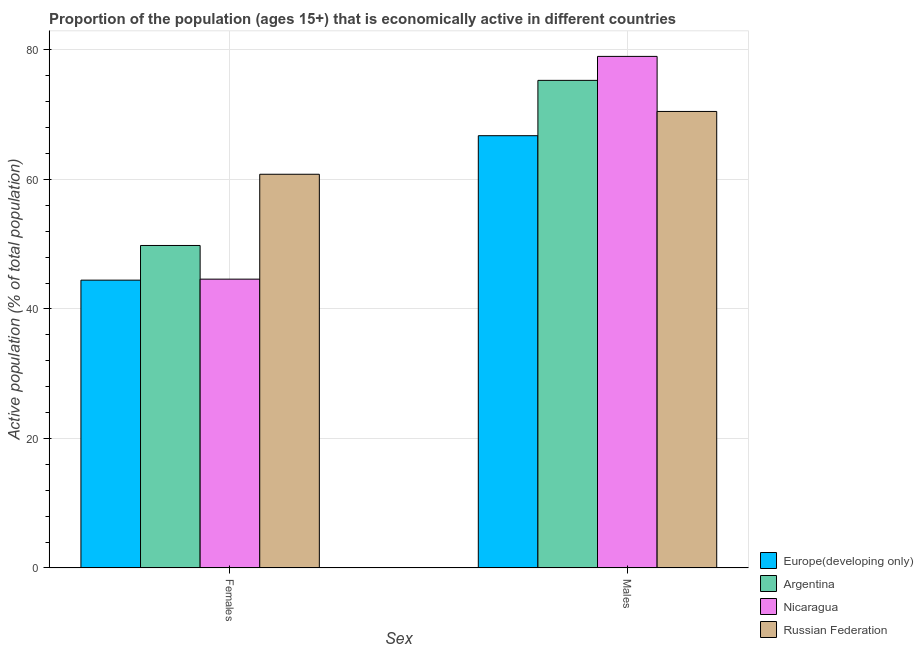How many different coloured bars are there?
Ensure brevity in your answer.  4. Are the number of bars per tick equal to the number of legend labels?
Offer a very short reply. Yes. Are the number of bars on each tick of the X-axis equal?
Your answer should be very brief. Yes. How many bars are there on the 2nd tick from the left?
Your answer should be compact. 4. What is the label of the 1st group of bars from the left?
Offer a very short reply. Females. What is the percentage of economically active female population in Argentina?
Keep it short and to the point. 49.8. Across all countries, what is the maximum percentage of economically active male population?
Offer a very short reply. 79. Across all countries, what is the minimum percentage of economically active female population?
Your answer should be very brief. 44.45. In which country was the percentage of economically active male population maximum?
Provide a succinct answer. Nicaragua. In which country was the percentage of economically active male population minimum?
Make the answer very short. Europe(developing only). What is the total percentage of economically active female population in the graph?
Offer a very short reply. 199.65. What is the difference between the percentage of economically active female population in Russian Federation and that in Nicaragua?
Provide a succinct answer. 16.2. What is the difference between the percentage of economically active male population in Russian Federation and the percentage of economically active female population in Nicaragua?
Provide a succinct answer. 25.9. What is the average percentage of economically active male population per country?
Provide a succinct answer. 72.89. What is the difference between the percentage of economically active female population and percentage of economically active male population in Russian Federation?
Your answer should be very brief. -9.7. What is the ratio of the percentage of economically active male population in Europe(developing only) to that in Nicaragua?
Provide a short and direct response. 0.84. Is the percentage of economically active female population in Nicaragua less than that in Europe(developing only)?
Your answer should be compact. No. What does the 1st bar from the left in Males represents?
Ensure brevity in your answer.  Europe(developing only). What does the 2nd bar from the right in Males represents?
Your answer should be compact. Nicaragua. How many bars are there?
Make the answer very short. 8. How many countries are there in the graph?
Provide a succinct answer. 4. What is the difference between two consecutive major ticks on the Y-axis?
Make the answer very short. 20. Are the values on the major ticks of Y-axis written in scientific E-notation?
Make the answer very short. No. Does the graph contain any zero values?
Ensure brevity in your answer.  No. Does the graph contain grids?
Your response must be concise. Yes. Where does the legend appear in the graph?
Ensure brevity in your answer.  Bottom right. What is the title of the graph?
Make the answer very short. Proportion of the population (ages 15+) that is economically active in different countries. What is the label or title of the X-axis?
Give a very brief answer. Sex. What is the label or title of the Y-axis?
Make the answer very short. Active population (% of total population). What is the Active population (% of total population) in Europe(developing only) in Females?
Make the answer very short. 44.45. What is the Active population (% of total population) of Argentina in Females?
Ensure brevity in your answer.  49.8. What is the Active population (% of total population) of Nicaragua in Females?
Keep it short and to the point. 44.6. What is the Active population (% of total population) of Russian Federation in Females?
Your answer should be compact. 60.8. What is the Active population (% of total population) of Europe(developing only) in Males?
Give a very brief answer. 66.75. What is the Active population (% of total population) in Argentina in Males?
Provide a short and direct response. 75.3. What is the Active population (% of total population) in Nicaragua in Males?
Your answer should be very brief. 79. What is the Active population (% of total population) of Russian Federation in Males?
Your answer should be very brief. 70.5. Across all Sex, what is the maximum Active population (% of total population) of Europe(developing only)?
Provide a succinct answer. 66.75. Across all Sex, what is the maximum Active population (% of total population) of Argentina?
Your answer should be very brief. 75.3. Across all Sex, what is the maximum Active population (% of total population) of Nicaragua?
Your response must be concise. 79. Across all Sex, what is the maximum Active population (% of total population) in Russian Federation?
Offer a very short reply. 70.5. Across all Sex, what is the minimum Active population (% of total population) of Europe(developing only)?
Provide a short and direct response. 44.45. Across all Sex, what is the minimum Active population (% of total population) in Argentina?
Keep it short and to the point. 49.8. Across all Sex, what is the minimum Active population (% of total population) of Nicaragua?
Provide a succinct answer. 44.6. Across all Sex, what is the minimum Active population (% of total population) in Russian Federation?
Ensure brevity in your answer.  60.8. What is the total Active population (% of total population) in Europe(developing only) in the graph?
Provide a short and direct response. 111.2. What is the total Active population (% of total population) in Argentina in the graph?
Provide a succinct answer. 125.1. What is the total Active population (% of total population) of Nicaragua in the graph?
Offer a terse response. 123.6. What is the total Active population (% of total population) in Russian Federation in the graph?
Offer a terse response. 131.3. What is the difference between the Active population (% of total population) of Europe(developing only) in Females and that in Males?
Offer a very short reply. -22.31. What is the difference between the Active population (% of total population) of Argentina in Females and that in Males?
Make the answer very short. -25.5. What is the difference between the Active population (% of total population) of Nicaragua in Females and that in Males?
Provide a short and direct response. -34.4. What is the difference between the Active population (% of total population) of Europe(developing only) in Females and the Active population (% of total population) of Argentina in Males?
Keep it short and to the point. -30.85. What is the difference between the Active population (% of total population) of Europe(developing only) in Females and the Active population (% of total population) of Nicaragua in Males?
Your answer should be compact. -34.55. What is the difference between the Active population (% of total population) of Europe(developing only) in Females and the Active population (% of total population) of Russian Federation in Males?
Offer a very short reply. -26.05. What is the difference between the Active population (% of total population) in Argentina in Females and the Active population (% of total population) in Nicaragua in Males?
Your answer should be compact. -29.2. What is the difference between the Active population (% of total population) in Argentina in Females and the Active population (% of total population) in Russian Federation in Males?
Offer a terse response. -20.7. What is the difference between the Active population (% of total population) of Nicaragua in Females and the Active population (% of total population) of Russian Federation in Males?
Keep it short and to the point. -25.9. What is the average Active population (% of total population) in Europe(developing only) per Sex?
Your answer should be very brief. 55.6. What is the average Active population (% of total population) in Argentina per Sex?
Provide a succinct answer. 62.55. What is the average Active population (% of total population) of Nicaragua per Sex?
Keep it short and to the point. 61.8. What is the average Active population (% of total population) in Russian Federation per Sex?
Offer a terse response. 65.65. What is the difference between the Active population (% of total population) in Europe(developing only) and Active population (% of total population) in Argentina in Females?
Keep it short and to the point. -5.35. What is the difference between the Active population (% of total population) in Europe(developing only) and Active population (% of total population) in Nicaragua in Females?
Ensure brevity in your answer.  -0.15. What is the difference between the Active population (% of total population) in Europe(developing only) and Active population (% of total population) in Russian Federation in Females?
Your response must be concise. -16.35. What is the difference between the Active population (% of total population) of Nicaragua and Active population (% of total population) of Russian Federation in Females?
Give a very brief answer. -16.2. What is the difference between the Active population (% of total population) of Europe(developing only) and Active population (% of total population) of Argentina in Males?
Offer a terse response. -8.55. What is the difference between the Active population (% of total population) of Europe(developing only) and Active population (% of total population) of Nicaragua in Males?
Ensure brevity in your answer.  -12.25. What is the difference between the Active population (% of total population) in Europe(developing only) and Active population (% of total population) in Russian Federation in Males?
Ensure brevity in your answer.  -3.75. What is the difference between the Active population (% of total population) of Argentina and Active population (% of total population) of Nicaragua in Males?
Make the answer very short. -3.7. What is the difference between the Active population (% of total population) of Argentina and Active population (% of total population) of Russian Federation in Males?
Make the answer very short. 4.8. What is the ratio of the Active population (% of total population) of Europe(developing only) in Females to that in Males?
Offer a terse response. 0.67. What is the ratio of the Active population (% of total population) in Argentina in Females to that in Males?
Ensure brevity in your answer.  0.66. What is the ratio of the Active population (% of total population) in Nicaragua in Females to that in Males?
Your answer should be very brief. 0.56. What is the ratio of the Active population (% of total population) in Russian Federation in Females to that in Males?
Your answer should be compact. 0.86. What is the difference between the highest and the second highest Active population (% of total population) of Europe(developing only)?
Keep it short and to the point. 22.31. What is the difference between the highest and the second highest Active population (% of total population) of Argentina?
Make the answer very short. 25.5. What is the difference between the highest and the second highest Active population (% of total population) in Nicaragua?
Offer a very short reply. 34.4. What is the difference between the highest and the lowest Active population (% of total population) in Europe(developing only)?
Your response must be concise. 22.31. What is the difference between the highest and the lowest Active population (% of total population) of Argentina?
Your answer should be very brief. 25.5. What is the difference between the highest and the lowest Active population (% of total population) of Nicaragua?
Your answer should be very brief. 34.4. 